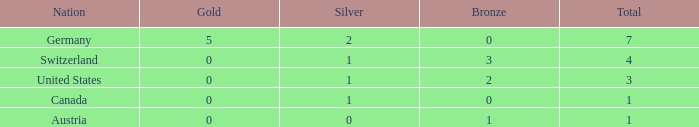What is the full amount of Total for Austria when the number of gold is less than 0? None. 